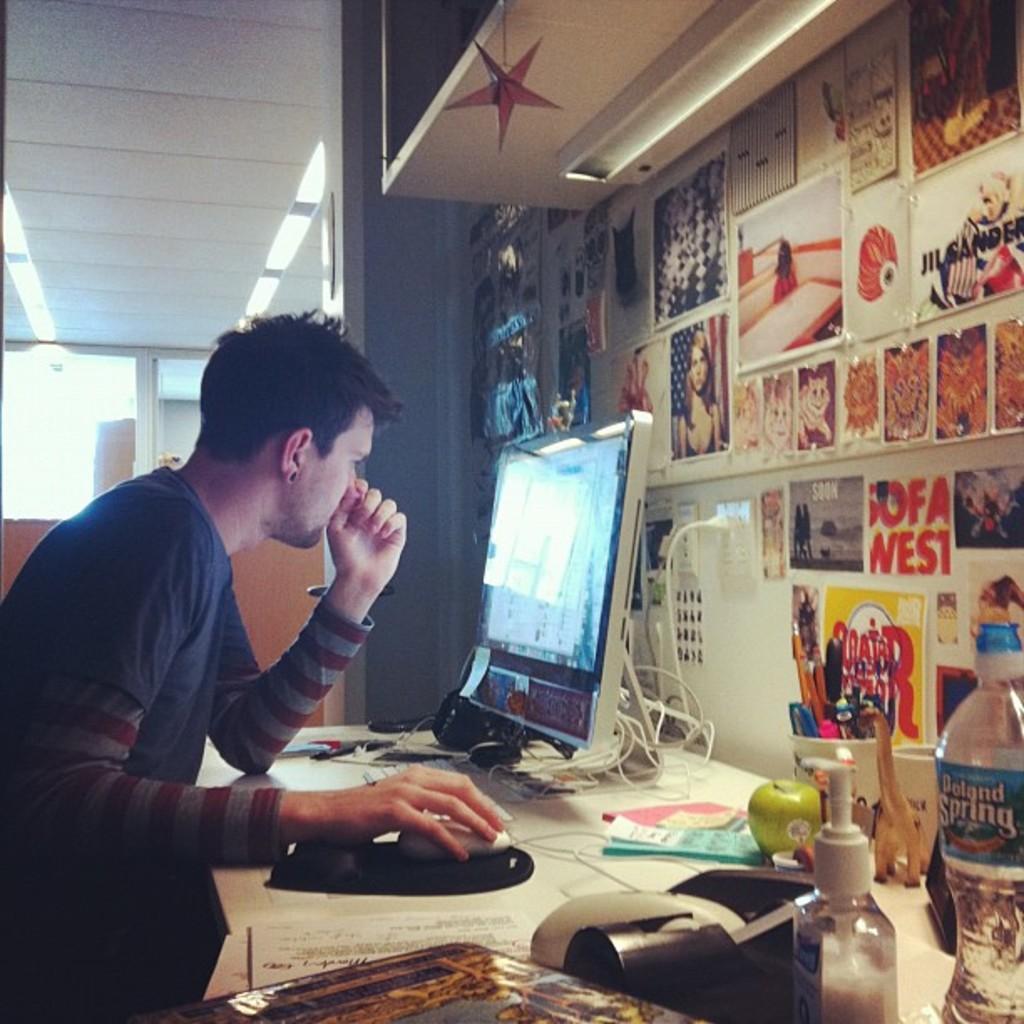Could you give a brief overview of what you see in this image? In this image on the left there is a man he holds a mouse he is staring at monitor. On the right there is monitor, table, bottle, apple, mouse, cup, pens, wall and photo frames. In the background there is a light. 